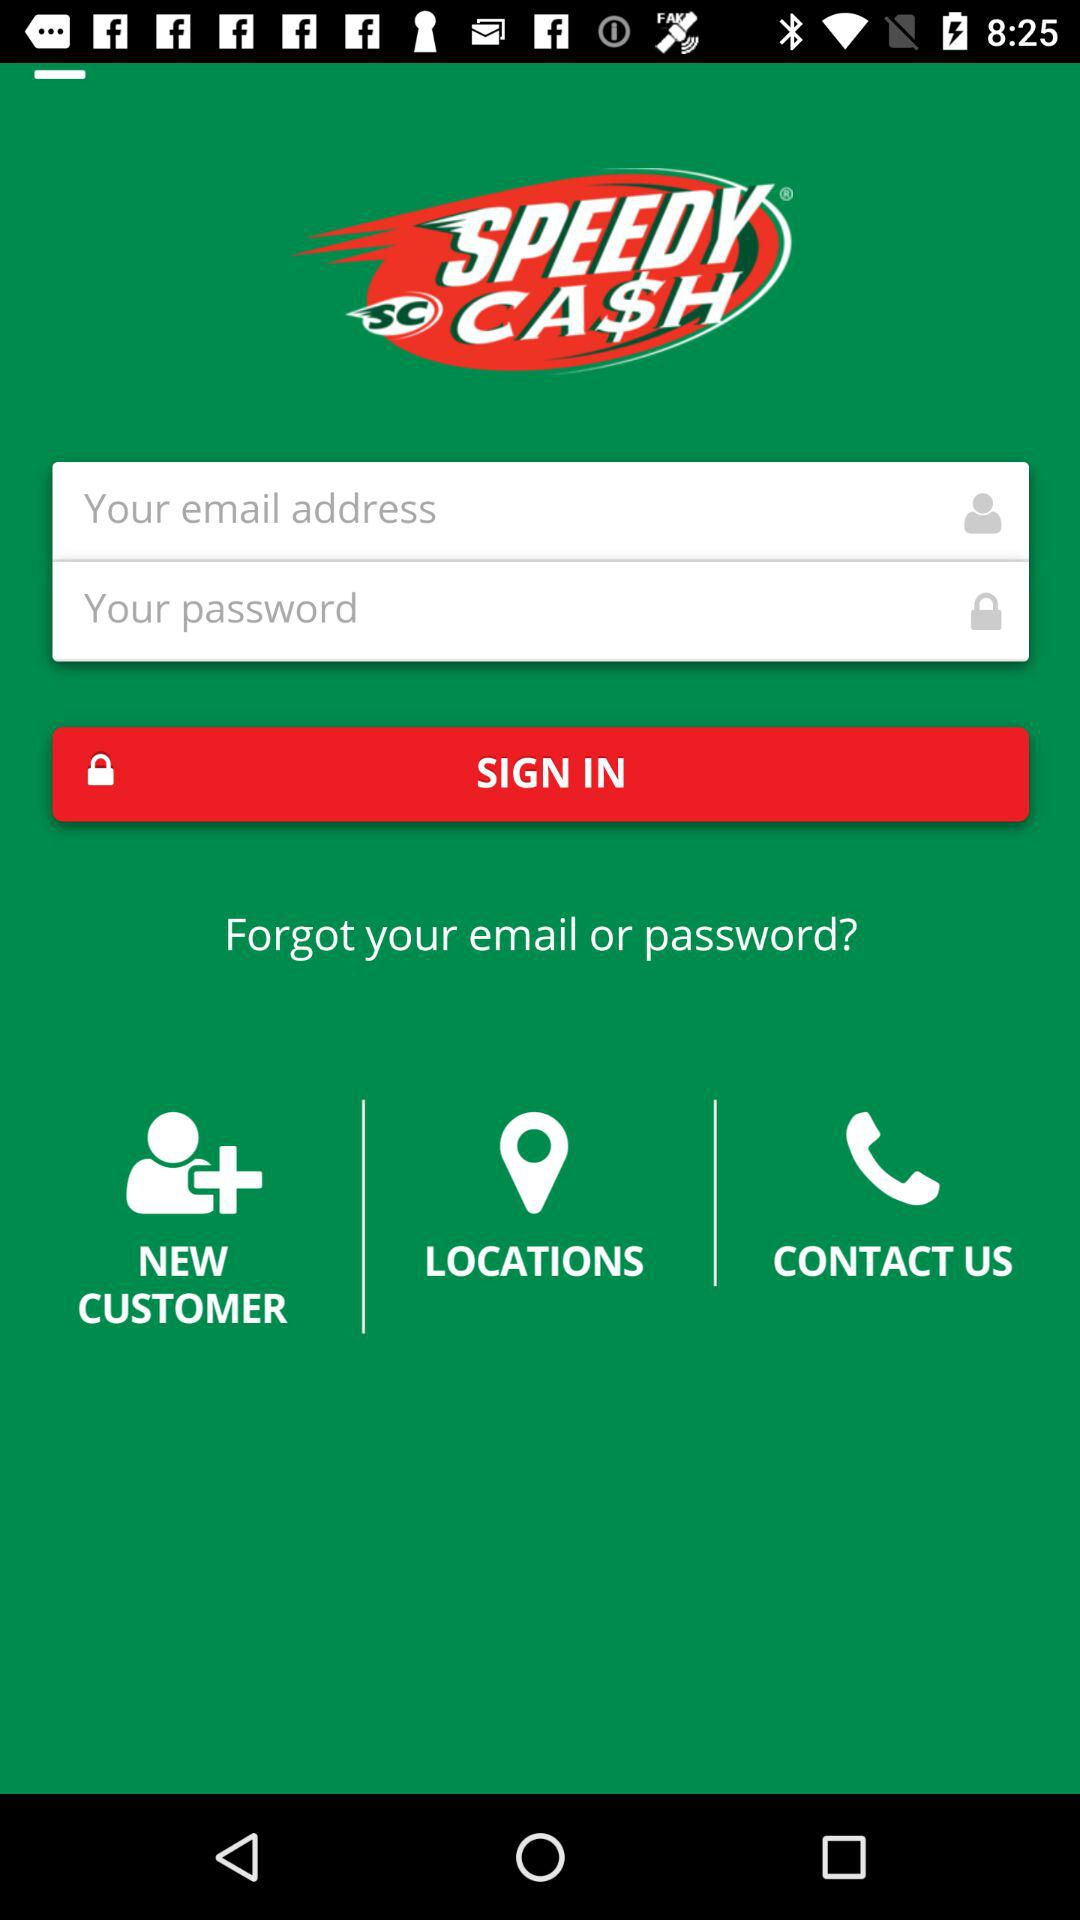Can we reset password?
When the provided information is insufficient, respond with <no answer>. <no answer> 